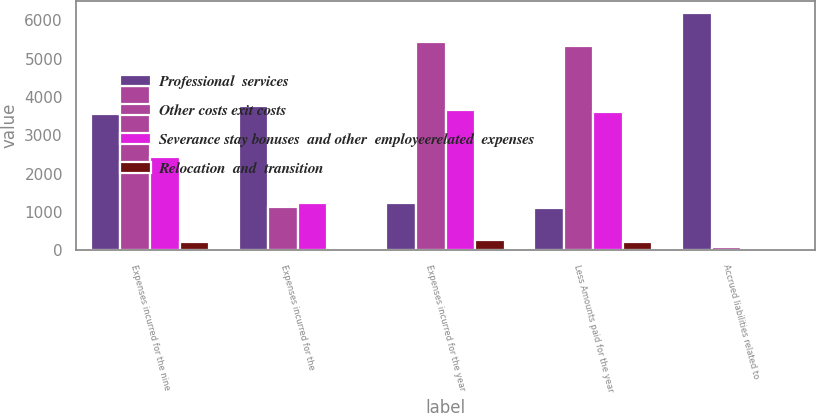Convert chart to OTSL. <chart><loc_0><loc_0><loc_500><loc_500><stacked_bar_chart><ecel><fcel>Expenses incurred for the nine<fcel>Expenses incurred for the<fcel>Expenses incurred for the year<fcel>Less Amounts paid for the year<fcel>Accrued liabilities related to<nl><fcel>Professional  services<fcel>3542<fcel>3760<fcel>1237<fcel>1107<fcel>6195<nl><fcel>Other costs exit costs<fcel>4294<fcel>1131<fcel>5425<fcel>5333<fcel>92<nl><fcel>Severance stay bonuses  and other  employeerelated  expenses<fcel>2425<fcel>1237<fcel>3662<fcel>3610<fcel>52<nl><fcel>Relocation  and  transition<fcel>223<fcel>38<fcel>261<fcel>222<fcel>39<nl></chart> 